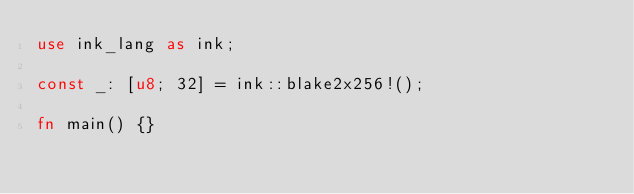<code> <loc_0><loc_0><loc_500><loc_500><_Rust_>use ink_lang as ink;

const _: [u8; 32] = ink::blake2x256!();

fn main() {}
</code> 